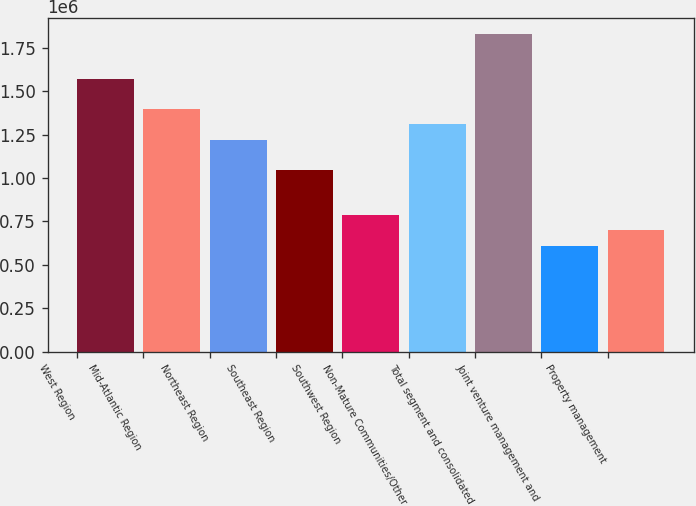Convert chart. <chart><loc_0><loc_0><loc_500><loc_500><bar_chart><fcel>West Region<fcel>Mid-Atlantic Region<fcel>Northeast Region<fcel>Southeast Region<fcel>Southwest Region<fcel>Non-Mature Communities/Other<fcel>Total segment and consolidated<fcel>Joint venture management and<fcel>Property management<nl><fcel>1.56947e+06<fcel>1.39508e+06<fcel>1.2207e+06<fcel>1.04631e+06<fcel>784736<fcel>1.30789e+06<fcel>1.83105e+06<fcel>610350<fcel>697543<nl></chart> 